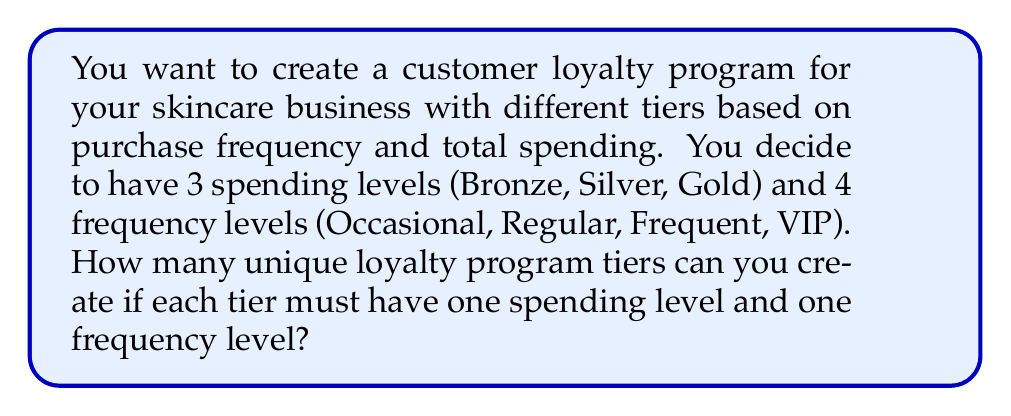Give your solution to this math problem. To solve this problem, we need to use the multiplication principle of counting. This principle states that if we have two independent choices, where the first choice has $m$ options and the second choice has $n$ options, then the total number of possible outcomes is $m \times n$.

In this case:
1. We have 3 spending levels: Bronze, Silver, Gold
2. We have 4 frequency levels: Occasional, Regular, Frequent, VIP

For each loyalty program tier, we need to choose:
- One spending level (3 options)
- One frequency level (4 options)

These choices are independent of each other, meaning that the choice of spending level doesn't affect the choice of frequency level, and vice versa.

Therefore, we can apply the multiplication principle:

$$ \text{Total unique tiers} = \text{Number of spending levels} \times \text{Number of frequency levels} $$

$$ \text{Total unique tiers} = 3 \times 4 = 12 $$

This means that we can create 12 unique loyalty program tiers, such as:
- Bronze Occasional
- Bronze Regular
- Bronze Frequent
- Bronze VIP
- Silver Occasional
- ...and so on, up to Gold VIP
Answer: $$ 12 \text{ unique loyalty program tiers} $$ 